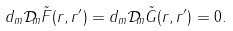<formula> <loc_0><loc_0><loc_500><loc_500>d _ { m } \mathcal { D } _ { m } \tilde { F } ( r , r ^ { \prime } ) = d _ { m } \mathcal { D } _ { m } \tilde { G } ( r , r ^ { \prime } ) = 0 .</formula> 